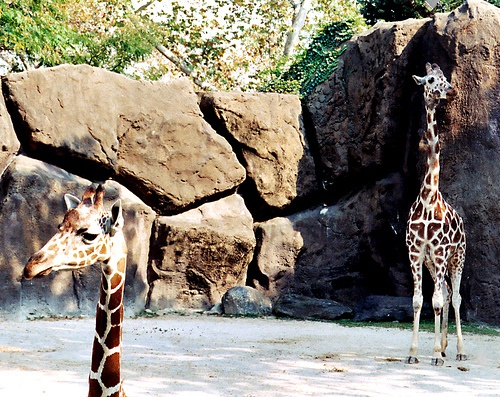Describe the objects in this image and their specific colors. I can see giraffe in olive, black, lightgray, darkgray, and maroon tones and giraffe in olive, white, black, maroon, and tan tones in this image. 